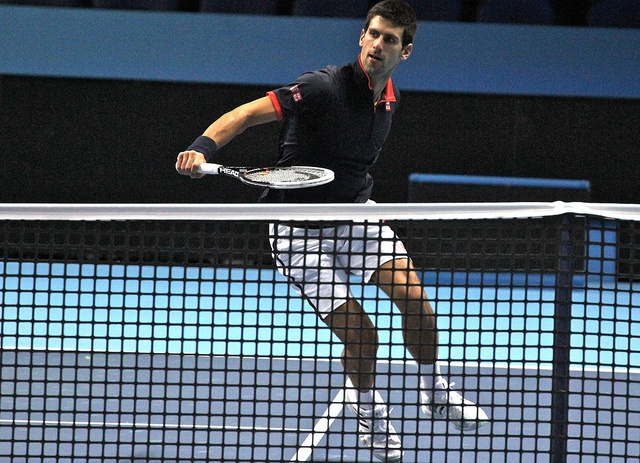Describe the objects in this image and their specific colors. I can see people in black, white, gray, and darkgray tones and tennis racket in black, lightgray, darkgray, and gray tones in this image. 